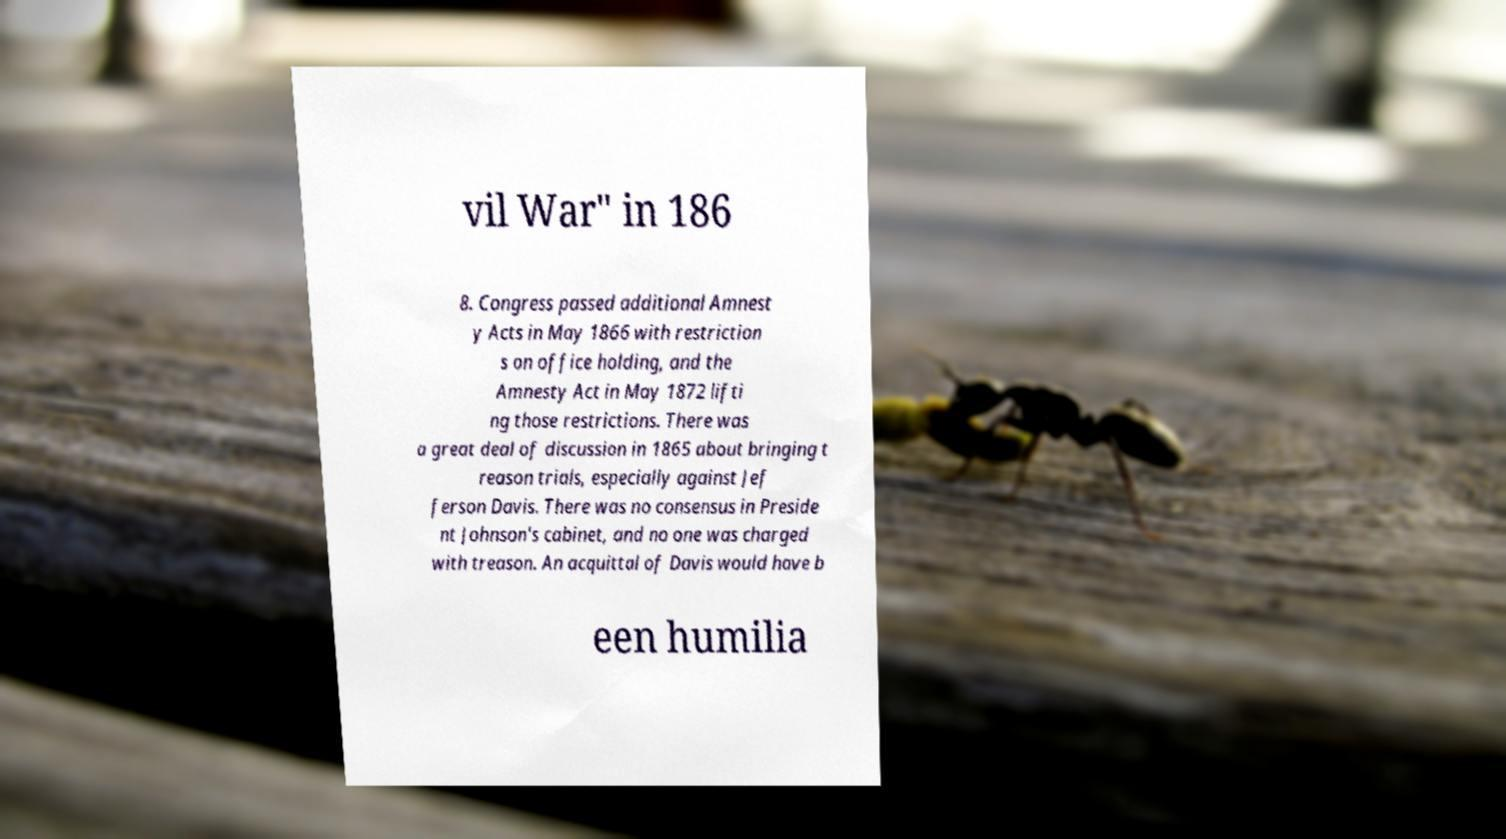Can you read and provide the text displayed in the image?This photo seems to have some interesting text. Can you extract and type it out for me? vil War" in 186 8. Congress passed additional Amnest y Acts in May 1866 with restriction s on office holding, and the Amnesty Act in May 1872 lifti ng those restrictions. There was a great deal of discussion in 1865 about bringing t reason trials, especially against Jef ferson Davis. There was no consensus in Preside nt Johnson's cabinet, and no one was charged with treason. An acquittal of Davis would have b een humilia 